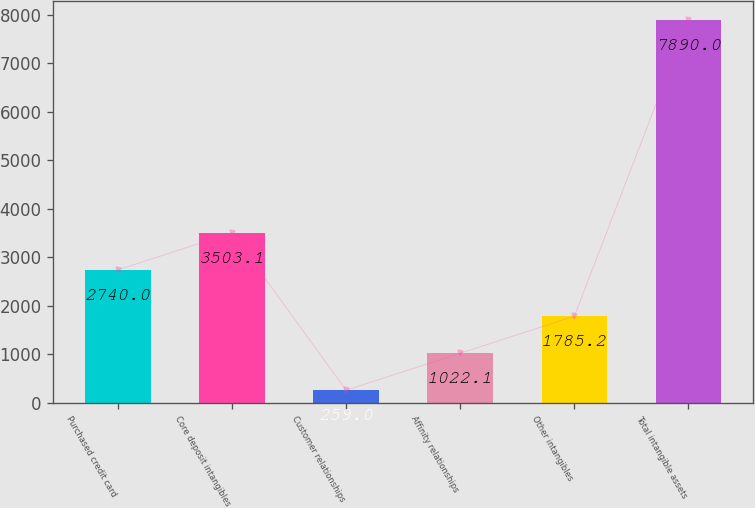Convert chart to OTSL. <chart><loc_0><loc_0><loc_500><loc_500><bar_chart><fcel>Purchased credit card<fcel>Core deposit intangibles<fcel>Customer relationships<fcel>Affinity relationships<fcel>Other intangibles<fcel>Total intangible assets<nl><fcel>2740<fcel>3503.1<fcel>259<fcel>1022.1<fcel>1785.2<fcel>7890<nl></chart> 